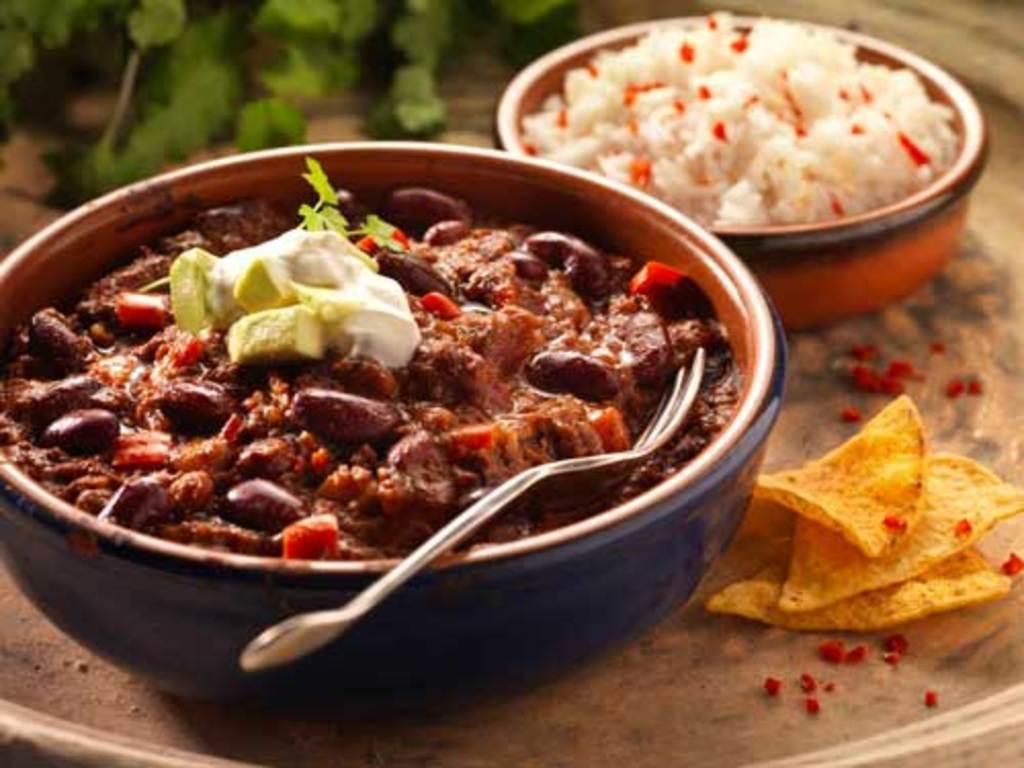Can you describe this image briefly? There is a curry, cream, leaf and fork in a bowl. Which is on the table. On the table, there are chips, rice in another bowl and leaves. 